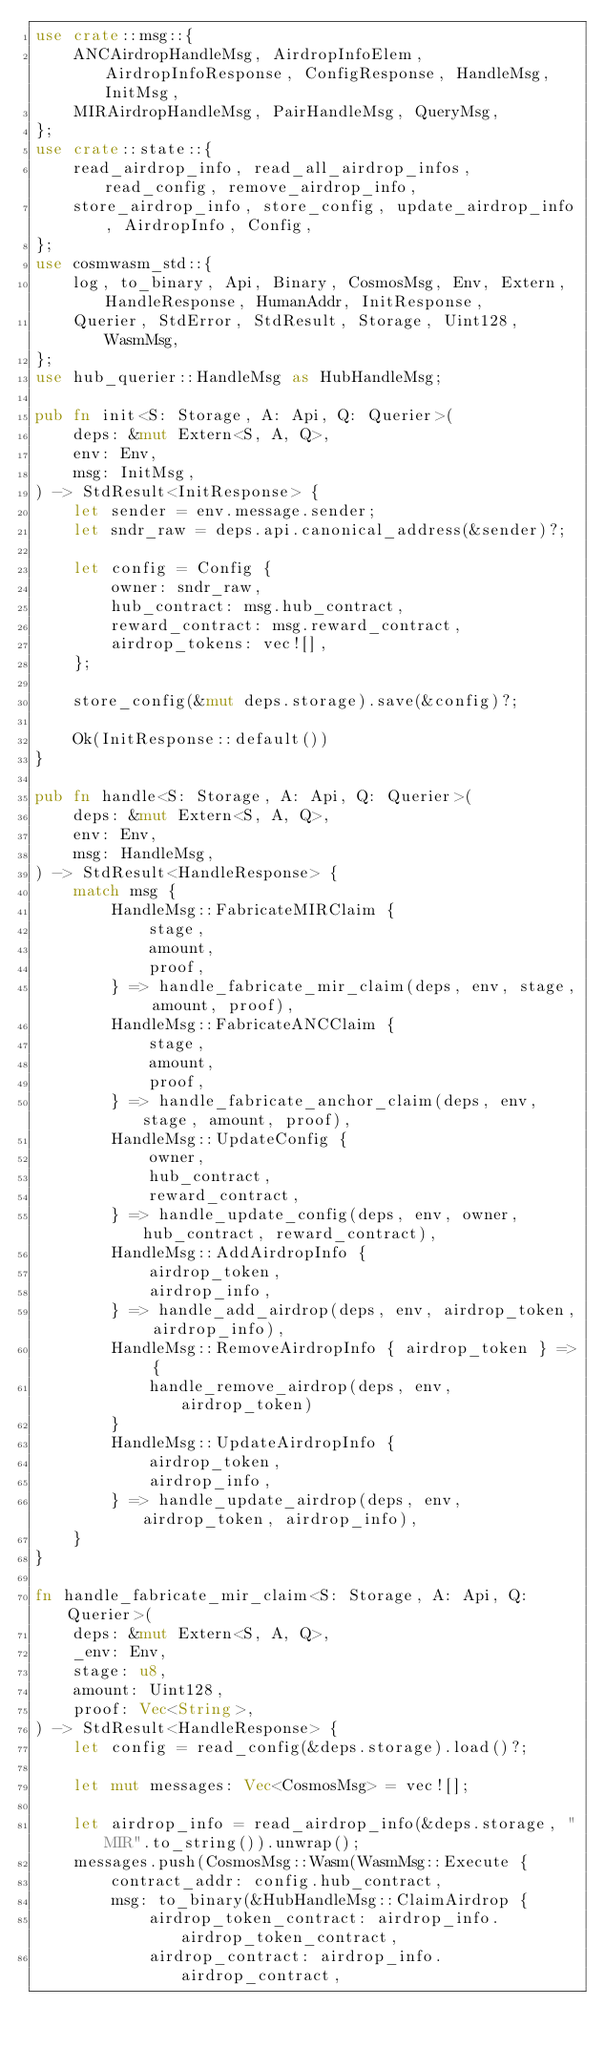<code> <loc_0><loc_0><loc_500><loc_500><_Rust_>use crate::msg::{
    ANCAirdropHandleMsg, AirdropInfoElem, AirdropInfoResponse, ConfigResponse, HandleMsg, InitMsg,
    MIRAirdropHandleMsg, PairHandleMsg, QueryMsg,
};
use crate::state::{
    read_airdrop_info, read_all_airdrop_infos, read_config, remove_airdrop_info,
    store_airdrop_info, store_config, update_airdrop_info, AirdropInfo, Config,
};
use cosmwasm_std::{
    log, to_binary, Api, Binary, CosmosMsg, Env, Extern, HandleResponse, HumanAddr, InitResponse,
    Querier, StdError, StdResult, Storage, Uint128, WasmMsg,
};
use hub_querier::HandleMsg as HubHandleMsg;

pub fn init<S: Storage, A: Api, Q: Querier>(
    deps: &mut Extern<S, A, Q>,
    env: Env,
    msg: InitMsg,
) -> StdResult<InitResponse> {
    let sender = env.message.sender;
    let sndr_raw = deps.api.canonical_address(&sender)?;

    let config = Config {
        owner: sndr_raw,
        hub_contract: msg.hub_contract,
        reward_contract: msg.reward_contract,
        airdrop_tokens: vec![],
    };

    store_config(&mut deps.storage).save(&config)?;

    Ok(InitResponse::default())
}

pub fn handle<S: Storage, A: Api, Q: Querier>(
    deps: &mut Extern<S, A, Q>,
    env: Env,
    msg: HandleMsg,
) -> StdResult<HandleResponse> {
    match msg {
        HandleMsg::FabricateMIRClaim {
            stage,
            amount,
            proof,
        } => handle_fabricate_mir_claim(deps, env, stage, amount, proof),
        HandleMsg::FabricateANCClaim {
            stage,
            amount,
            proof,
        } => handle_fabricate_anchor_claim(deps, env, stage, amount, proof),
        HandleMsg::UpdateConfig {
            owner,
            hub_contract,
            reward_contract,
        } => handle_update_config(deps, env, owner, hub_contract, reward_contract),
        HandleMsg::AddAirdropInfo {
            airdrop_token,
            airdrop_info,
        } => handle_add_airdrop(deps, env, airdrop_token, airdrop_info),
        HandleMsg::RemoveAirdropInfo { airdrop_token } => {
            handle_remove_airdrop(deps, env, airdrop_token)
        }
        HandleMsg::UpdateAirdropInfo {
            airdrop_token,
            airdrop_info,
        } => handle_update_airdrop(deps, env, airdrop_token, airdrop_info),
    }
}

fn handle_fabricate_mir_claim<S: Storage, A: Api, Q: Querier>(
    deps: &mut Extern<S, A, Q>,
    _env: Env,
    stage: u8,
    amount: Uint128,
    proof: Vec<String>,
) -> StdResult<HandleResponse> {
    let config = read_config(&deps.storage).load()?;

    let mut messages: Vec<CosmosMsg> = vec![];

    let airdrop_info = read_airdrop_info(&deps.storage, "MIR".to_string()).unwrap();
    messages.push(CosmosMsg::Wasm(WasmMsg::Execute {
        contract_addr: config.hub_contract,
        msg: to_binary(&HubHandleMsg::ClaimAirdrop {
            airdrop_token_contract: airdrop_info.airdrop_token_contract,
            airdrop_contract: airdrop_info.airdrop_contract,</code> 